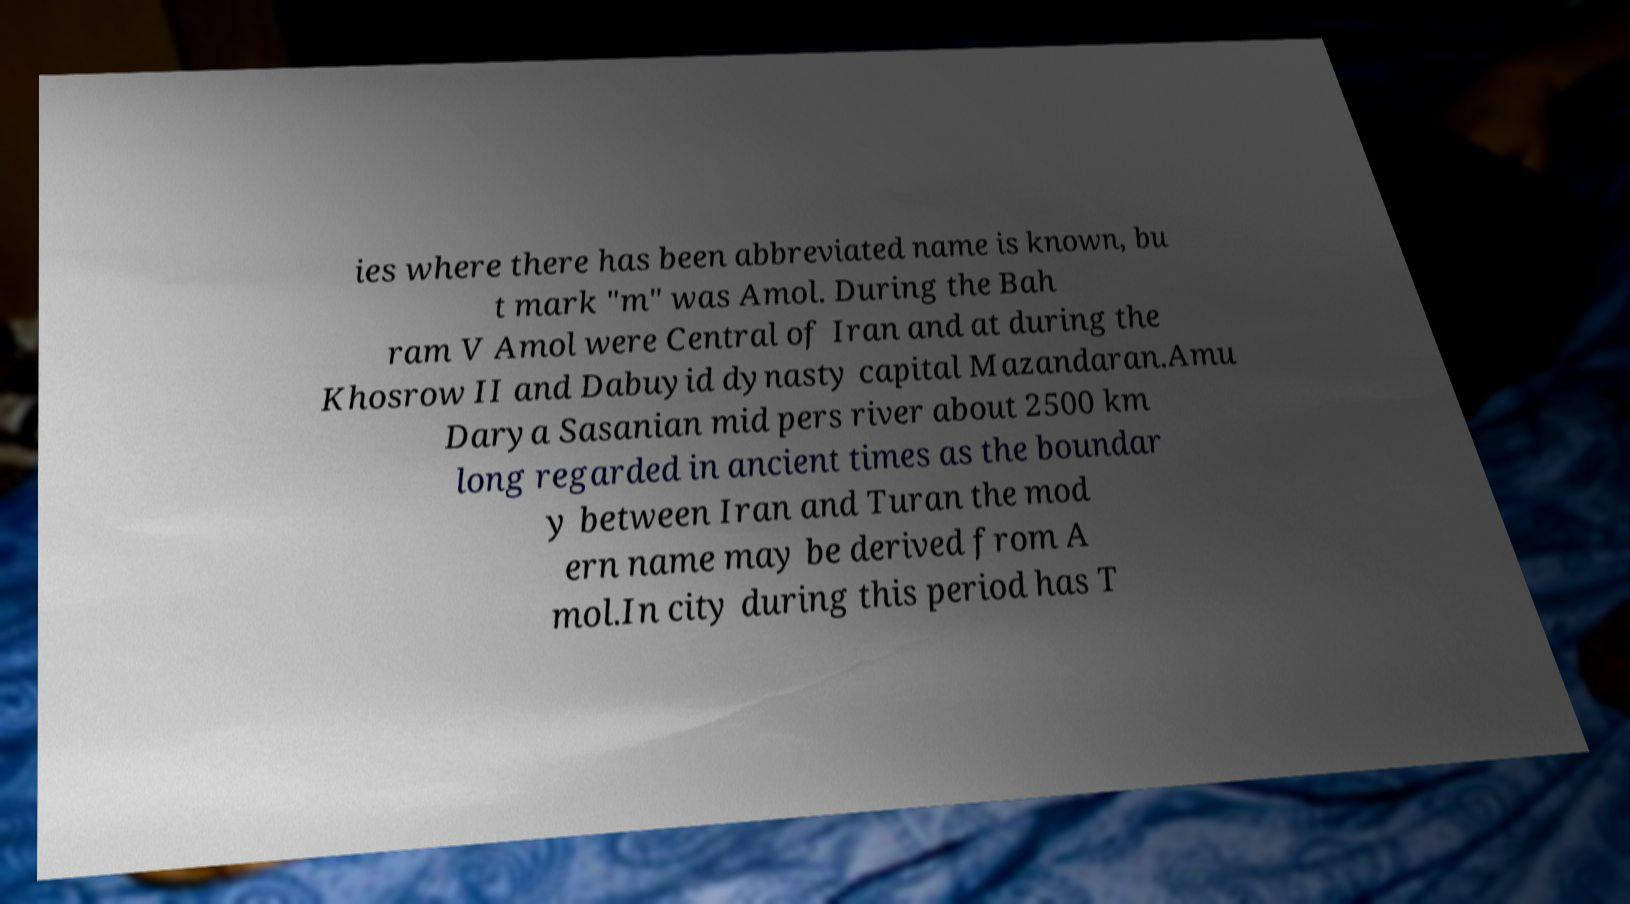Please identify and transcribe the text found in this image. ies where there has been abbreviated name is known, bu t mark "m" was Amol. During the Bah ram V Amol were Central of Iran and at during the Khosrow II and Dabuyid dynasty capital Mazandaran.Amu Darya Sasanian mid pers river about 2500 km long regarded in ancient times as the boundar y between Iran and Turan the mod ern name may be derived from A mol.In city during this period has T 